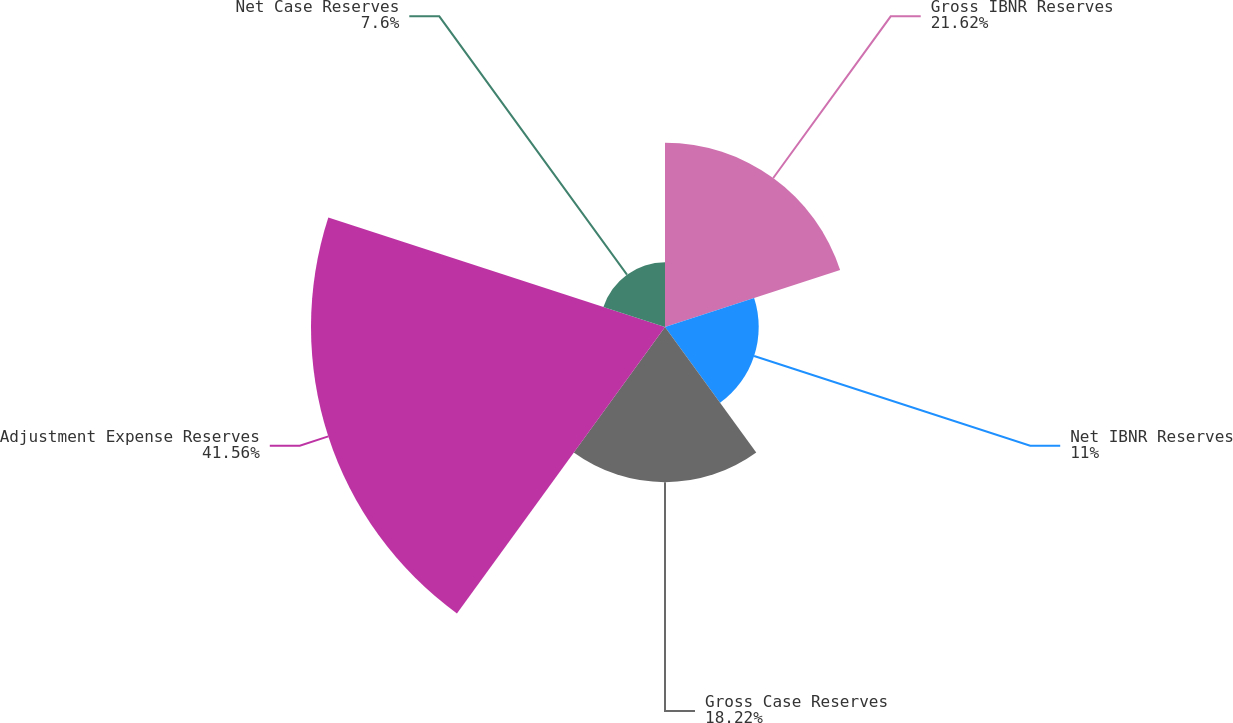Convert chart to OTSL. <chart><loc_0><loc_0><loc_500><loc_500><pie_chart><fcel>Gross IBNR Reserves<fcel>Net IBNR Reserves<fcel>Gross Case Reserves<fcel>Adjustment Expense Reserves<fcel>Net Case Reserves<nl><fcel>21.62%<fcel>11.0%<fcel>18.22%<fcel>41.56%<fcel>7.6%<nl></chart> 